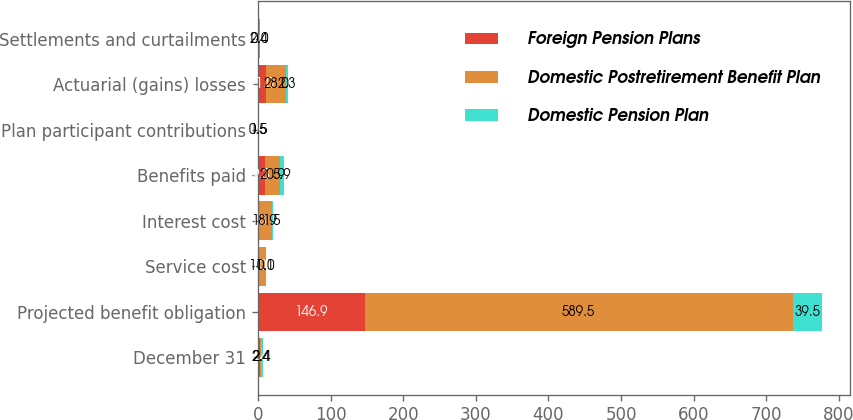Convert chart to OTSL. <chart><loc_0><loc_0><loc_500><loc_500><stacked_bar_chart><ecel><fcel>December 31<fcel>Projected benefit obligation<fcel>Service cost<fcel>Interest cost<fcel>Benefits paid<fcel>Plan participant contributions<fcel>Actuarial (gains) losses<fcel>Settlements and curtailments<nl><fcel>Foreign Pension Plans<fcel>2.4<fcel>146.9<fcel>0<fcel>0.3<fcel>9.3<fcel>0<fcel>11<fcel>0<nl><fcel>Domestic Postretirement Benefit Plan<fcel>2.4<fcel>589.5<fcel>11.1<fcel>18.9<fcel>20.9<fcel>0.5<fcel>28<fcel>2.4<nl><fcel>Domestic Pension Plan<fcel>2.4<fcel>39.5<fcel>0<fcel>1.5<fcel>5.9<fcel>1.5<fcel>2.3<fcel>0<nl></chart> 